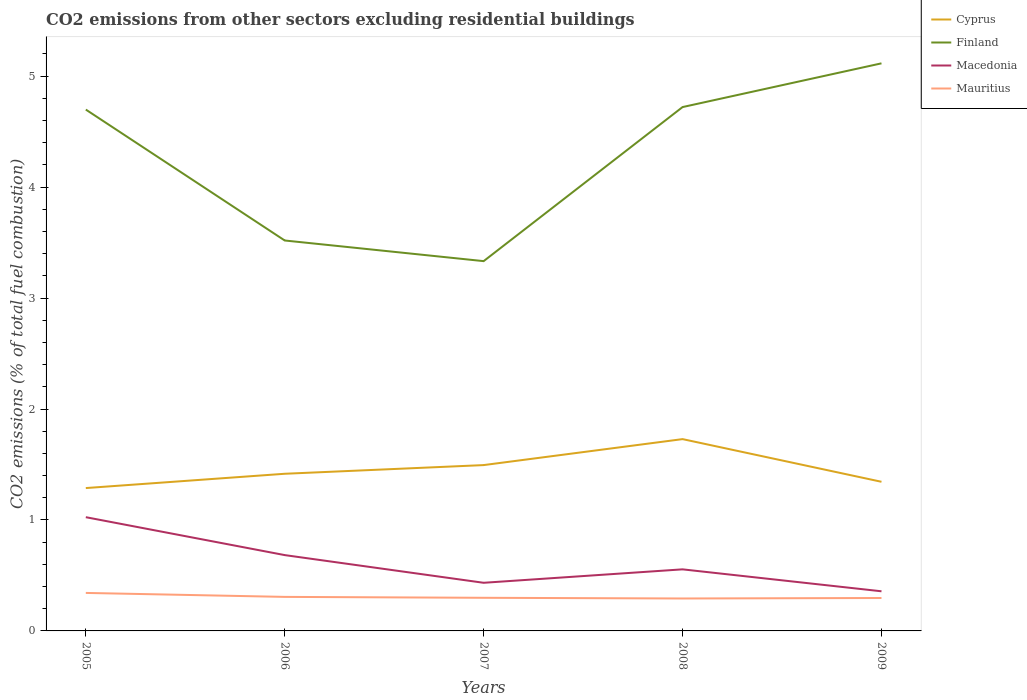Is the number of lines equal to the number of legend labels?
Provide a short and direct response. Yes. Across all years, what is the maximum total CO2 emitted in Macedonia?
Provide a short and direct response. 0.36. In which year was the total CO2 emitted in Mauritius maximum?
Offer a terse response. 2008. What is the total total CO2 emitted in Mauritius in the graph?
Your answer should be compact. 0.04. What is the difference between the highest and the second highest total CO2 emitted in Cyprus?
Your response must be concise. 0.44. How many years are there in the graph?
Give a very brief answer. 5. What is the difference between two consecutive major ticks on the Y-axis?
Your answer should be very brief. 1. Are the values on the major ticks of Y-axis written in scientific E-notation?
Make the answer very short. No. Does the graph contain any zero values?
Your answer should be very brief. No. How are the legend labels stacked?
Provide a short and direct response. Vertical. What is the title of the graph?
Keep it short and to the point. CO2 emissions from other sectors excluding residential buildings. What is the label or title of the Y-axis?
Your answer should be very brief. CO2 emissions (% of total fuel combustion). What is the CO2 emissions (% of total fuel combustion) in Cyprus in 2005?
Offer a very short reply. 1.29. What is the CO2 emissions (% of total fuel combustion) of Finland in 2005?
Keep it short and to the point. 4.7. What is the CO2 emissions (% of total fuel combustion) in Macedonia in 2005?
Make the answer very short. 1.03. What is the CO2 emissions (% of total fuel combustion) of Mauritius in 2005?
Provide a succinct answer. 0.34. What is the CO2 emissions (% of total fuel combustion) in Cyprus in 2006?
Offer a very short reply. 1.42. What is the CO2 emissions (% of total fuel combustion) of Finland in 2006?
Provide a succinct answer. 3.52. What is the CO2 emissions (% of total fuel combustion) in Macedonia in 2006?
Provide a short and direct response. 0.68. What is the CO2 emissions (% of total fuel combustion) of Mauritius in 2006?
Keep it short and to the point. 0.31. What is the CO2 emissions (% of total fuel combustion) in Cyprus in 2007?
Make the answer very short. 1.49. What is the CO2 emissions (% of total fuel combustion) in Finland in 2007?
Your response must be concise. 3.33. What is the CO2 emissions (% of total fuel combustion) in Macedonia in 2007?
Provide a short and direct response. 0.43. What is the CO2 emissions (% of total fuel combustion) in Mauritius in 2007?
Offer a very short reply. 0.3. What is the CO2 emissions (% of total fuel combustion) in Cyprus in 2008?
Your answer should be compact. 1.73. What is the CO2 emissions (% of total fuel combustion) of Finland in 2008?
Make the answer very short. 4.72. What is the CO2 emissions (% of total fuel combustion) of Macedonia in 2008?
Your response must be concise. 0.55. What is the CO2 emissions (% of total fuel combustion) of Mauritius in 2008?
Provide a succinct answer. 0.29. What is the CO2 emissions (% of total fuel combustion) of Cyprus in 2009?
Offer a very short reply. 1.34. What is the CO2 emissions (% of total fuel combustion) of Finland in 2009?
Make the answer very short. 5.12. What is the CO2 emissions (% of total fuel combustion) of Macedonia in 2009?
Give a very brief answer. 0.36. What is the CO2 emissions (% of total fuel combustion) in Mauritius in 2009?
Your answer should be compact. 0.3. Across all years, what is the maximum CO2 emissions (% of total fuel combustion) in Cyprus?
Ensure brevity in your answer.  1.73. Across all years, what is the maximum CO2 emissions (% of total fuel combustion) in Finland?
Make the answer very short. 5.12. Across all years, what is the maximum CO2 emissions (% of total fuel combustion) of Macedonia?
Provide a succinct answer. 1.03. Across all years, what is the maximum CO2 emissions (% of total fuel combustion) of Mauritius?
Your answer should be compact. 0.34. Across all years, what is the minimum CO2 emissions (% of total fuel combustion) of Cyprus?
Your response must be concise. 1.29. Across all years, what is the minimum CO2 emissions (% of total fuel combustion) in Finland?
Ensure brevity in your answer.  3.33. Across all years, what is the minimum CO2 emissions (% of total fuel combustion) in Macedonia?
Provide a short and direct response. 0.36. Across all years, what is the minimum CO2 emissions (% of total fuel combustion) in Mauritius?
Offer a terse response. 0.29. What is the total CO2 emissions (% of total fuel combustion) of Cyprus in the graph?
Your answer should be very brief. 7.27. What is the total CO2 emissions (% of total fuel combustion) of Finland in the graph?
Keep it short and to the point. 21.39. What is the total CO2 emissions (% of total fuel combustion) in Macedonia in the graph?
Your response must be concise. 3.05. What is the total CO2 emissions (% of total fuel combustion) in Mauritius in the graph?
Make the answer very short. 1.54. What is the difference between the CO2 emissions (% of total fuel combustion) in Cyprus in 2005 and that in 2006?
Offer a very short reply. -0.13. What is the difference between the CO2 emissions (% of total fuel combustion) of Finland in 2005 and that in 2006?
Your answer should be compact. 1.18. What is the difference between the CO2 emissions (% of total fuel combustion) of Macedonia in 2005 and that in 2006?
Your answer should be compact. 0.34. What is the difference between the CO2 emissions (% of total fuel combustion) of Mauritius in 2005 and that in 2006?
Offer a terse response. 0.04. What is the difference between the CO2 emissions (% of total fuel combustion) in Cyprus in 2005 and that in 2007?
Offer a very short reply. -0.21. What is the difference between the CO2 emissions (% of total fuel combustion) in Finland in 2005 and that in 2007?
Provide a succinct answer. 1.37. What is the difference between the CO2 emissions (% of total fuel combustion) in Macedonia in 2005 and that in 2007?
Keep it short and to the point. 0.59. What is the difference between the CO2 emissions (% of total fuel combustion) of Mauritius in 2005 and that in 2007?
Give a very brief answer. 0.04. What is the difference between the CO2 emissions (% of total fuel combustion) of Cyprus in 2005 and that in 2008?
Keep it short and to the point. -0.44. What is the difference between the CO2 emissions (% of total fuel combustion) in Finland in 2005 and that in 2008?
Keep it short and to the point. -0.02. What is the difference between the CO2 emissions (% of total fuel combustion) of Macedonia in 2005 and that in 2008?
Ensure brevity in your answer.  0.47. What is the difference between the CO2 emissions (% of total fuel combustion) of Mauritius in 2005 and that in 2008?
Ensure brevity in your answer.  0.05. What is the difference between the CO2 emissions (% of total fuel combustion) in Cyprus in 2005 and that in 2009?
Offer a terse response. -0.06. What is the difference between the CO2 emissions (% of total fuel combustion) of Finland in 2005 and that in 2009?
Offer a very short reply. -0.42. What is the difference between the CO2 emissions (% of total fuel combustion) in Macedonia in 2005 and that in 2009?
Your answer should be very brief. 0.67. What is the difference between the CO2 emissions (% of total fuel combustion) of Mauritius in 2005 and that in 2009?
Your response must be concise. 0.05. What is the difference between the CO2 emissions (% of total fuel combustion) in Cyprus in 2006 and that in 2007?
Make the answer very short. -0.08. What is the difference between the CO2 emissions (% of total fuel combustion) of Finland in 2006 and that in 2007?
Your answer should be very brief. 0.19. What is the difference between the CO2 emissions (% of total fuel combustion) of Macedonia in 2006 and that in 2007?
Provide a succinct answer. 0.25. What is the difference between the CO2 emissions (% of total fuel combustion) in Mauritius in 2006 and that in 2007?
Provide a succinct answer. 0.01. What is the difference between the CO2 emissions (% of total fuel combustion) of Cyprus in 2006 and that in 2008?
Keep it short and to the point. -0.31. What is the difference between the CO2 emissions (% of total fuel combustion) in Finland in 2006 and that in 2008?
Keep it short and to the point. -1.2. What is the difference between the CO2 emissions (% of total fuel combustion) in Macedonia in 2006 and that in 2008?
Make the answer very short. 0.13. What is the difference between the CO2 emissions (% of total fuel combustion) of Mauritius in 2006 and that in 2008?
Offer a very short reply. 0.01. What is the difference between the CO2 emissions (% of total fuel combustion) in Cyprus in 2006 and that in 2009?
Your answer should be compact. 0.07. What is the difference between the CO2 emissions (% of total fuel combustion) of Finland in 2006 and that in 2009?
Give a very brief answer. -1.6. What is the difference between the CO2 emissions (% of total fuel combustion) in Macedonia in 2006 and that in 2009?
Your answer should be very brief. 0.33. What is the difference between the CO2 emissions (% of total fuel combustion) of Mauritius in 2006 and that in 2009?
Your answer should be very brief. 0.01. What is the difference between the CO2 emissions (% of total fuel combustion) in Cyprus in 2007 and that in 2008?
Ensure brevity in your answer.  -0.23. What is the difference between the CO2 emissions (% of total fuel combustion) of Finland in 2007 and that in 2008?
Your response must be concise. -1.39. What is the difference between the CO2 emissions (% of total fuel combustion) of Macedonia in 2007 and that in 2008?
Make the answer very short. -0.12. What is the difference between the CO2 emissions (% of total fuel combustion) in Mauritius in 2007 and that in 2008?
Provide a succinct answer. 0.01. What is the difference between the CO2 emissions (% of total fuel combustion) in Cyprus in 2007 and that in 2009?
Keep it short and to the point. 0.15. What is the difference between the CO2 emissions (% of total fuel combustion) of Finland in 2007 and that in 2009?
Your response must be concise. -1.78. What is the difference between the CO2 emissions (% of total fuel combustion) in Macedonia in 2007 and that in 2009?
Make the answer very short. 0.08. What is the difference between the CO2 emissions (% of total fuel combustion) in Mauritius in 2007 and that in 2009?
Offer a terse response. 0. What is the difference between the CO2 emissions (% of total fuel combustion) in Cyprus in 2008 and that in 2009?
Make the answer very short. 0.38. What is the difference between the CO2 emissions (% of total fuel combustion) of Finland in 2008 and that in 2009?
Ensure brevity in your answer.  -0.39. What is the difference between the CO2 emissions (% of total fuel combustion) in Macedonia in 2008 and that in 2009?
Your answer should be very brief. 0.2. What is the difference between the CO2 emissions (% of total fuel combustion) in Mauritius in 2008 and that in 2009?
Keep it short and to the point. -0. What is the difference between the CO2 emissions (% of total fuel combustion) in Cyprus in 2005 and the CO2 emissions (% of total fuel combustion) in Finland in 2006?
Offer a terse response. -2.23. What is the difference between the CO2 emissions (% of total fuel combustion) of Cyprus in 2005 and the CO2 emissions (% of total fuel combustion) of Macedonia in 2006?
Provide a succinct answer. 0.6. What is the difference between the CO2 emissions (% of total fuel combustion) in Cyprus in 2005 and the CO2 emissions (% of total fuel combustion) in Mauritius in 2006?
Provide a succinct answer. 0.98. What is the difference between the CO2 emissions (% of total fuel combustion) of Finland in 2005 and the CO2 emissions (% of total fuel combustion) of Macedonia in 2006?
Keep it short and to the point. 4.02. What is the difference between the CO2 emissions (% of total fuel combustion) in Finland in 2005 and the CO2 emissions (% of total fuel combustion) in Mauritius in 2006?
Ensure brevity in your answer.  4.39. What is the difference between the CO2 emissions (% of total fuel combustion) of Macedonia in 2005 and the CO2 emissions (% of total fuel combustion) of Mauritius in 2006?
Provide a short and direct response. 0.72. What is the difference between the CO2 emissions (% of total fuel combustion) in Cyprus in 2005 and the CO2 emissions (% of total fuel combustion) in Finland in 2007?
Offer a very short reply. -2.05. What is the difference between the CO2 emissions (% of total fuel combustion) of Cyprus in 2005 and the CO2 emissions (% of total fuel combustion) of Macedonia in 2007?
Offer a terse response. 0.85. What is the difference between the CO2 emissions (% of total fuel combustion) in Finland in 2005 and the CO2 emissions (% of total fuel combustion) in Macedonia in 2007?
Offer a terse response. 4.26. What is the difference between the CO2 emissions (% of total fuel combustion) in Finland in 2005 and the CO2 emissions (% of total fuel combustion) in Mauritius in 2007?
Your response must be concise. 4.4. What is the difference between the CO2 emissions (% of total fuel combustion) in Macedonia in 2005 and the CO2 emissions (% of total fuel combustion) in Mauritius in 2007?
Keep it short and to the point. 0.73. What is the difference between the CO2 emissions (% of total fuel combustion) of Cyprus in 2005 and the CO2 emissions (% of total fuel combustion) of Finland in 2008?
Provide a succinct answer. -3.43. What is the difference between the CO2 emissions (% of total fuel combustion) in Cyprus in 2005 and the CO2 emissions (% of total fuel combustion) in Macedonia in 2008?
Your answer should be compact. 0.73. What is the difference between the CO2 emissions (% of total fuel combustion) of Finland in 2005 and the CO2 emissions (% of total fuel combustion) of Macedonia in 2008?
Provide a short and direct response. 4.14. What is the difference between the CO2 emissions (% of total fuel combustion) of Finland in 2005 and the CO2 emissions (% of total fuel combustion) of Mauritius in 2008?
Provide a succinct answer. 4.41. What is the difference between the CO2 emissions (% of total fuel combustion) of Macedonia in 2005 and the CO2 emissions (% of total fuel combustion) of Mauritius in 2008?
Offer a terse response. 0.73. What is the difference between the CO2 emissions (% of total fuel combustion) in Cyprus in 2005 and the CO2 emissions (% of total fuel combustion) in Finland in 2009?
Give a very brief answer. -3.83. What is the difference between the CO2 emissions (% of total fuel combustion) in Cyprus in 2005 and the CO2 emissions (% of total fuel combustion) in Macedonia in 2009?
Offer a very short reply. 0.93. What is the difference between the CO2 emissions (% of total fuel combustion) in Cyprus in 2005 and the CO2 emissions (% of total fuel combustion) in Mauritius in 2009?
Keep it short and to the point. 0.99. What is the difference between the CO2 emissions (% of total fuel combustion) of Finland in 2005 and the CO2 emissions (% of total fuel combustion) of Macedonia in 2009?
Offer a very short reply. 4.34. What is the difference between the CO2 emissions (% of total fuel combustion) in Finland in 2005 and the CO2 emissions (% of total fuel combustion) in Mauritius in 2009?
Provide a succinct answer. 4.4. What is the difference between the CO2 emissions (% of total fuel combustion) of Macedonia in 2005 and the CO2 emissions (% of total fuel combustion) of Mauritius in 2009?
Your answer should be compact. 0.73. What is the difference between the CO2 emissions (% of total fuel combustion) in Cyprus in 2006 and the CO2 emissions (% of total fuel combustion) in Finland in 2007?
Offer a very short reply. -1.92. What is the difference between the CO2 emissions (% of total fuel combustion) of Cyprus in 2006 and the CO2 emissions (% of total fuel combustion) of Macedonia in 2007?
Offer a terse response. 0.98. What is the difference between the CO2 emissions (% of total fuel combustion) in Cyprus in 2006 and the CO2 emissions (% of total fuel combustion) in Mauritius in 2007?
Provide a short and direct response. 1.12. What is the difference between the CO2 emissions (% of total fuel combustion) of Finland in 2006 and the CO2 emissions (% of total fuel combustion) of Macedonia in 2007?
Your answer should be very brief. 3.08. What is the difference between the CO2 emissions (% of total fuel combustion) of Finland in 2006 and the CO2 emissions (% of total fuel combustion) of Mauritius in 2007?
Offer a terse response. 3.22. What is the difference between the CO2 emissions (% of total fuel combustion) of Macedonia in 2006 and the CO2 emissions (% of total fuel combustion) of Mauritius in 2007?
Offer a terse response. 0.38. What is the difference between the CO2 emissions (% of total fuel combustion) of Cyprus in 2006 and the CO2 emissions (% of total fuel combustion) of Finland in 2008?
Your response must be concise. -3.3. What is the difference between the CO2 emissions (% of total fuel combustion) of Cyprus in 2006 and the CO2 emissions (% of total fuel combustion) of Macedonia in 2008?
Offer a very short reply. 0.86. What is the difference between the CO2 emissions (% of total fuel combustion) in Cyprus in 2006 and the CO2 emissions (% of total fuel combustion) in Mauritius in 2008?
Give a very brief answer. 1.12. What is the difference between the CO2 emissions (% of total fuel combustion) in Finland in 2006 and the CO2 emissions (% of total fuel combustion) in Macedonia in 2008?
Your answer should be very brief. 2.96. What is the difference between the CO2 emissions (% of total fuel combustion) in Finland in 2006 and the CO2 emissions (% of total fuel combustion) in Mauritius in 2008?
Offer a terse response. 3.23. What is the difference between the CO2 emissions (% of total fuel combustion) of Macedonia in 2006 and the CO2 emissions (% of total fuel combustion) of Mauritius in 2008?
Offer a very short reply. 0.39. What is the difference between the CO2 emissions (% of total fuel combustion) in Cyprus in 2006 and the CO2 emissions (% of total fuel combustion) in Finland in 2009?
Offer a very short reply. -3.7. What is the difference between the CO2 emissions (% of total fuel combustion) in Cyprus in 2006 and the CO2 emissions (% of total fuel combustion) in Macedonia in 2009?
Give a very brief answer. 1.06. What is the difference between the CO2 emissions (% of total fuel combustion) in Cyprus in 2006 and the CO2 emissions (% of total fuel combustion) in Mauritius in 2009?
Provide a succinct answer. 1.12. What is the difference between the CO2 emissions (% of total fuel combustion) in Finland in 2006 and the CO2 emissions (% of total fuel combustion) in Macedonia in 2009?
Ensure brevity in your answer.  3.16. What is the difference between the CO2 emissions (% of total fuel combustion) in Finland in 2006 and the CO2 emissions (% of total fuel combustion) in Mauritius in 2009?
Make the answer very short. 3.22. What is the difference between the CO2 emissions (% of total fuel combustion) in Macedonia in 2006 and the CO2 emissions (% of total fuel combustion) in Mauritius in 2009?
Provide a succinct answer. 0.39. What is the difference between the CO2 emissions (% of total fuel combustion) in Cyprus in 2007 and the CO2 emissions (% of total fuel combustion) in Finland in 2008?
Offer a terse response. -3.23. What is the difference between the CO2 emissions (% of total fuel combustion) in Cyprus in 2007 and the CO2 emissions (% of total fuel combustion) in Macedonia in 2008?
Ensure brevity in your answer.  0.94. What is the difference between the CO2 emissions (% of total fuel combustion) in Cyprus in 2007 and the CO2 emissions (% of total fuel combustion) in Mauritius in 2008?
Provide a succinct answer. 1.2. What is the difference between the CO2 emissions (% of total fuel combustion) in Finland in 2007 and the CO2 emissions (% of total fuel combustion) in Macedonia in 2008?
Provide a short and direct response. 2.78. What is the difference between the CO2 emissions (% of total fuel combustion) of Finland in 2007 and the CO2 emissions (% of total fuel combustion) of Mauritius in 2008?
Give a very brief answer. 3.04. What is the difference between the CO2 emissions (% of total fuel combustion) of Macedonia in 2007 and the CO2 emissions (% of total fuel combustion) of Mauritius in 2008?
Your answer should be compact. 0.14. What is the difference between the CO2 emissions (% of total fuel combustion) of Cyprus in 2007 and the CO2 emissions (% of total fuel combustion) of Finland in 2009?
Ensure brevity in your answer.  -3.62. What is the difference between the CO2 emissions (% of total fuel combustion) of Cyprus in 2007 and the CO2 emissions (% of total fuel combustion) of Macedonia in 2009?
Your answer should be compact. 1.14. What is the difference between the CO2 emissions (% of total fuel combustion) of Cyprus in 2007 and the CO2 emissions (% of total fuel combustion) of Mauritius in 2009?
Provide a succinct answer. 1.2. What is the difference between the CO2 emissions (% of total fuel combustion) of Finland in 2007 and the CO2 emissions (% of total fuel combustion) of Macedonia in 2009?
Offer a very short reply. 2.98. What is the difference between the CO2 emissions (% of total fuel combustion) in Finland in 2007 and the CO2 emissions (% of total fuel combustion) in Mauritius in 2009?
Provide a succinct answer. 3.04. What is the difference between the CO2 emissions (% of total fuel combustion) of Macedonia in 2007 and the CO2 emissions (% of total fuel combustion) of Mauritius in 2009?
Your answer should be compact. 0.14. What is the difference between the CO2 emissions (% of total fuel combustion) in Cyprus in 2008 and the CO2 emissions (% of total fuel combustion) in Finland in 2009?
Provide a short and direct response. -3.39. What is the difference between the CO2 emissions (% of total fuel combustion) of Cyprus in 2008 and the CO2 emissions (% of total fuel combustion) of Macedonia in 2009?
Provide a succinct answer. 1.37. What is the difference between the CO2 emissions (% of total fuel combustion) of Cyprus in 2008 and the CO2 emissions (% of total fuel combustion) of Mauritius in 2009?
Give a very brief answer. 1.43. What is the difference between the CO2 emissions (% of total fuel combustion) in Finland in 2008 and the CO2 emissions (% of total fuel combustion) in Macedonia in 2009?
Keep it short and to the point. 4.36. What is the difference between the CO2 emissions (% of total fuel combustion) of Finland in 2008 and the CO2 emissions (% of total fuel combustion) of Mauritius in 2009?
Provide a succinct answer. 4.42. What is the difference between the CO2 emissions (% of total fuel combustion) of Macedonia in 2008 and the CO2 emissions (% of total fuel combustion) of Mauritius in 2009?
Make the answer very short. 0.26. What is the average CO2 emissions (% of total fuel combustion) in Cyprus per year?
Make the answer very short. 1.45. What is the average CO2 emissions (% of total fuel combustion) in Finland per year?
Your response must be concise. 4.28. What is the average CO2 emissions (% of total fuel combustion) of Macedonia per year?
Provide a short and direct response. 0.61. What is the average CO2 emissions (% of total fuel combustion) in Mauritius per year?
Your response must be concise. 0.31. In the year 2005, what is the difference between the CO2 emissions (% of total fuel combustion) of Cyprus and CO2 emissions (% of total fuel combustion) of Finland?
Offer a very short reply. -3.41. In the year 2005, what is the difference between the CO2 emissions (% of total fuel combustion) of Cyprus and CO2 emissions (% of total fuel combustion) of Macedonia?
Your answer should be very brief. 0.26. In the year 2005, what is the difference between the CO2 emissions (% of total fuel combustion) of Cyprus and CO2 emissions (% of total fuel combustion) of Mauritius?
Give a very brief answer. 0.95. In the year 2005, what is the difference between the CO2 emissions (% of total fuel combustion) in Finland and CO2 emissions (% of total fuel combustion) in Macedonia?
Provide a short and direct response. 3.67. In the year 2005, what is the difference between the CO2 emissions (% of total fuel combustion) of Finland and CO2 emissions (% of total fuel combustion) of Mauritius?
Offer a very short reply. 4.36. In the year 2005, what is the difference between the CO2 emissions (% of total fuel combustion) in Macedonia and CO2 emissions (% of total fuel combustion) in Mauritius?
Offer a terse response. 0.68. In the year 2006, what is the difference between the CO2 emissions (% of total fuel combustion) in Cyprus and CO2 emissions (% of total fuel combustion) in Finland?
Offer a very short reply. -2.1. In the year 2006, what is the difference between the CO2 emissions (% of total fuel combustion) of Cyprus and CO2 emissions (% of total fuel combustion) of Macedonia?
Make the answer very short. 0.73. In the year 2006, what is the difference between the CO2 emissions (% of total fuel combustion) in Cyprus and CO2 emissions (% of total fuel combustion) in Mauritius?
Your answer should be very brief. 1.11. In the year 2006, what is the difference between the CO2 emissions (% of total fuel combustion) in Finland and CO2 emissions (% of total fuel combustion) in Macedonia?
Provide a short and direct response. 2.84. In the year 2006, what is the difference between the CO2 emissions (% of total fuel combustion) of Finland and CO2 emissions (% of total fuel combustion) of Mauritius?
Give a very brief answer. 3.21. In the year 2006, what is the difference between the CO2 emissions (% of total fuel combustion) of Macedonia and CO2 emissions (% of total fuel combustion) of Mauritius?
Your answer should be very brief. 0.38. In the year 2007, what is the difference between the CO2 emissions (% of total fuel combustion) in Cyprus and CO2 emissions (% of total fuel combustion) in Finland?
Your answer should be very brief. -1.84. In the year 2007, what is the difference between the CO2 emissions (% of total fuel combustion) in Cyprus and CO2 emissions (% of total fuel combustion) in Macedonia?
Give a very brief answer. 1.06. In the year 2007, what is the difference between the CO2 emissions (% of total fuel combustion) in Cyprus and CO2 emissions (% of total fuel combustion) in Mauritius?
Provide a succinct answer. 1.2. In the year 2007, what is the difference between the CO2 emissions (% of total fuel combustion) of Finland and CO2 emissions (% of total fuel combustion) of Macedonia?
Give a very brief answer. 2.9. In the year 2007, what is the difference between the CO2 emissions (% of total fuel combustion) in Finland and CO2 emissions (% of total fuel combustion) in Mauritius?
Give a very brief answer. 3.03. In the year 2007, what is the difference between the CO2 emissions (% of total fuel combustion) of Macedonia and CO2 emissions (% of total fuel combustion) of Mauritius?
Keep it short and to the point. 0.14. In the year 2008, what is the difference between the CO2 emissions (% of total fuel combustion) of Cyprus and CO2 emissions (% of total fuel combustion) of Finland?
Make the answer very short. -2.99. In the year 2008, what is the difference between the CO2 emissions (% of total fuel combustion) of Cyprus and CO2 emissions (% of total fuel combustion) of Macedonia?
Ensure brevity in your answer.  1.17. In the year 2008, what is the difference between the CO2 emissions (% of total fuel combustion) in Cyprus and CO2 emissions (% of total fuel combustion) in Mauritius?
Ensure brevity in your answer.  1.44. In the year 2008, what is the difference between the CO2 emissions (% of total fuel combustion) of Finland and CO2 emissions (% of total fuel combustion) of Macedonia?
Offer a terse response. 4.17. In the year 2008, what is the difference between the CO2 emissions (% of total fuel combustion) of Finland and CO2 emissions (% of total fuel combustion) of Mauritius?
Offer a terse response. 4.43. In the year 2008, what is the difference between the CO2 emissions (% of total fuel combustion) in Macedonia and CO2 emissions (% of total fuel combustion) in Mauritius?
Make the answer very short. 0.26. In the year 2009, what is the difference between the CO2 emissions (% of total fuel combustion) in Cyprus and CO2 emissions (% of total fuel combustion) in Finland?
Your answer should be compact. -3.77. In the year 2009, what is the difference between the CO2 emissions (% of total fuel combustion) in Cyprus and CO2 emissions (% of total fuel combustion) in Macedonia?
Make the answer very short. 0.99. In the year 2009, what is the difference between the CO2 emissions (% of total fuel combustion) in Cyprus and CO2 emissions (% of total fuel combustion) in Mauritius?
Provide a succinct answer. 1.05. In the year 2009, what is the difference between the CO2 emissions (% of total fuel combustion) in Finland and CO2 emissions (% of total fuel combustion) in Macedonia?
Make the answer very short. 4.76. In the year 2009, what is the difference between the CO2 emissions (% of total fuel combustion) of Finland and CO2 emissions (% of total fuel combustion) of Mauritius?
Your response must be concise. 4.82. In the year 2009, what is the difference between the CO2 emissions (% of total fuel combustion) in Macedonia and CO2 emissions (% of total fuel combustion) in Mauritius?
Keep it short and to the point. 0.06. What is the ratio of the CO2 emissions (% of total fuel combustion) of Cyprus in 2005 to that in 2006?
Make the answer very short. 0.91. What is the ratio of the CO2 emissions (% of total fuel combustion) in Finland in 2005 to that in 2006?
Provide a short and direct response. 1.34. What is the ratio of the CO2 emissions (% of total fuel combustion) of Macedonia in 2005 to that in 2006?
Your response must be concise. 1.5. What is the ratio of the CO2 emissions (% of total fuel combustion) in Mauritius in 2005 to that in 2006?
Give a very brief answer. 1.12. What is the ratio of the CO2 emissions (% of total fuel combustion) of Cyprus in 2005 to that in 2007?
Offer a terse response. 0.86. What is the ratio of the CO2 emissions (% of total fuel combustion) of Finland in 2005 to that in 2007?
Ensure brevity in your answer.  1.41. What is the ratio of the CO2 emissions (% of total fuel combustion) of Macedonia in 2005 to that in 2007?
Offer a terse response. 2.36. What is the ratio of the CO2 emissions (% of total fuel combustion) in Mauritius in 2005 to that in 2007?
Offer a terse response. 1.15. What is the ratio of the CO2 emissions (% of total fuel combustion) in Cyprus in 2005 to that in 2008?
Your answer should be compact. 0.74. What is the ratio of the CO2 emissions (% of total fuel combustion) of Macedonia in 2005 to that in 2008?
Ensure brevity in your answer.  1.85. What is the ratio of the CO2 emissions (% of total fuel combustion) in Mauritius in 2005 to that in 2008?
Your answer should be compact. 1.17. What is the ratio of the CO2 emissions (% of total fuel combustion) in Cyprus in 2005 to that in 2009?
Your answer should be very brief. 0.96. What is the ratio of the CO2 emissions (% of total fuel combustion) of Finland in 2005 to that in 2009?
Your response must be concise. 0.92. What is the ratio of the CO2 emissions (% of total fuel combustion) in Macedonia in 2005 to that in 2009?
Ensure brevity in your answer.  2.87. What is the ratio of the CO2 emissions (% of total fuel combustion) in Mauritius in 2005 to that in 2009?
Offer a very short reply. 1.15. What is the ratio of the CO2 emissions (% of total fuel combustion) in Cyprus in 2006 to that in 2007?
Provide a short and direct response. 0.95. What is the ratio of the CO2 emissions (% of total fuel combustion) of Finland in 2006 to that in 2007?
Offer a terse response. 1.06. What is the ratio of the CO2 emissions (% of total fuel combustion) of Macedonia in 2006 to that in 2007?
Give a very brief answer. 1.58. What is the ratio of the CO2 emissions (% of total fuel combustion) of Mauritius in 2006 to that in 2007?
Give a very brief answer. 1.03. What is the ratio of the CO2 emissions (% of total fuel combustion) in Cyprus in 2006 to that in 2008?
Your answer should be compact. 0.82. What is the ratio of the CO2 emissions (% of total fuel combustion) in Finland in 2006 to that in 2008?
Provide a short and direct response. 0.75. What is the ratio of the CO2 emissions (% of total fuel combustion) of Macedonia in 2006 to that in 2008?
Offer a very short reply. 1.23. What is the ratio of the CO2 emissions (% of total fuel combustion) of Mauritius in 2006 to that in 2008?
Provide a succinct answer. 1.05. What is the ratio of the CO2 emissions (% of total fuel combustion) of Cyprus in 2006 to that in 2009?
Provide a short and direct response. 1.05. What is the ratio of the CO2 emissions (% of total fuel combustion) in Finland in 2006 to that in 2009?
Provide a short and direct response. 0.69. What is the ratio of the CO2 emissions (% of total fuel combustion) in Macedonia in 2006 to that in 2009?
Provide a short and direct response. 1.91. What is the ratio of the CO2 emissions (% of total fuel combustion) in Mauritius in 2006 to that in 2009?
Your response must be concise. 1.03. What is the ratio of the CO2 emissions (% of total fuel combustion) of Cyprus in 2007 to that in 2008?
Give a very brief answer. 0.86. What is the ratio of the CO2 emissions (% of total fuel combustion) of Finland in 2007 to that in 2008?
Provide a succinct answer. 0.71. What is the ratio of the CO2 emissions (% of total fuel combustion) in Macedonia in 2007 to that in 2008?
Keep it short and to the point. 0.78. What is the ratio of the CO2 emissions (% of total fuel combustion) in Mauritius in 2007 to that in 2008?
Ensure brevity in your answer.  1.02. What is the ratio of the CO2 emissions (% of total fuel combustion) of Cyprus in 2007 to that in 2009?
Keep it short and to the point. 1.11. What is the ratio of the CO2 emissions (% of total fuel combustion) in Finland in 2007 to that in 2009?
Your response must be concise. 0.65. What is the ratio of the CO2 emissions (% of total fuel combustion) of Macedonia in 2007 to that in 2009?
Your answer should be compact. 1.21. What is the ratio of the CO2 emissions (% of total fuel combustion) in Cyprus in 2008 to that in 2009?
Provide a short and direct response. 1.29. What is the ratio of the CO2 emissions (% of total fuel combustion) of Finland in 2008 to that in 2009?
Provide a short and direct response. 0.92. What is the ratio of the CO2 emissions (% of total fuel combustion) in Macedonia in 2008 to that in 2009?
Provide a succinct answer. 1.55. What is the ratio of the CO2 emissions (% of total fuel combustion) of Mauritius in 2008 to that in 2009?
Your response must be concise. 0.99. What is the difference between the highest and the second highest CO2 emissions (% of total fuel combustion) in Cyprus?
Offer a terse response. 0.23. What is the difference between the highest and the second highest CO2 emissions (% of total fuel combustion) of Finland?
Provide a succinct answer. 0.39. What is the difference between the highest and the second highest CO2 emissions (% of total fuel combustion) in Macedonia?
Your answer should be compact. 0.34. What is the difference between the highest and the second highest CO2 emissions (% of total fuel combustion) in Mauritius?
Ensure brevity in your answer.  0.04. What is the difference between the highest and the lowest CO2 emissions (% of total fuel combustion) in Cyprus?
Give a very brief answer. 0.44. What is the difference between the highest and the lowest CO2 emissions (% of total fuel combustion) of Finland?
Your answer should be very brief. 1.78. What is the difference between the highest and the lowest CO2 emissions (% of total fuel combustion) in Macedonia?
Your response must be concise. 0.67. What is the difference between the highest and the lowest CO2 emissions (% of total fuel combustion) of Mauritius?
Your answer should be very brief. 0.05. 